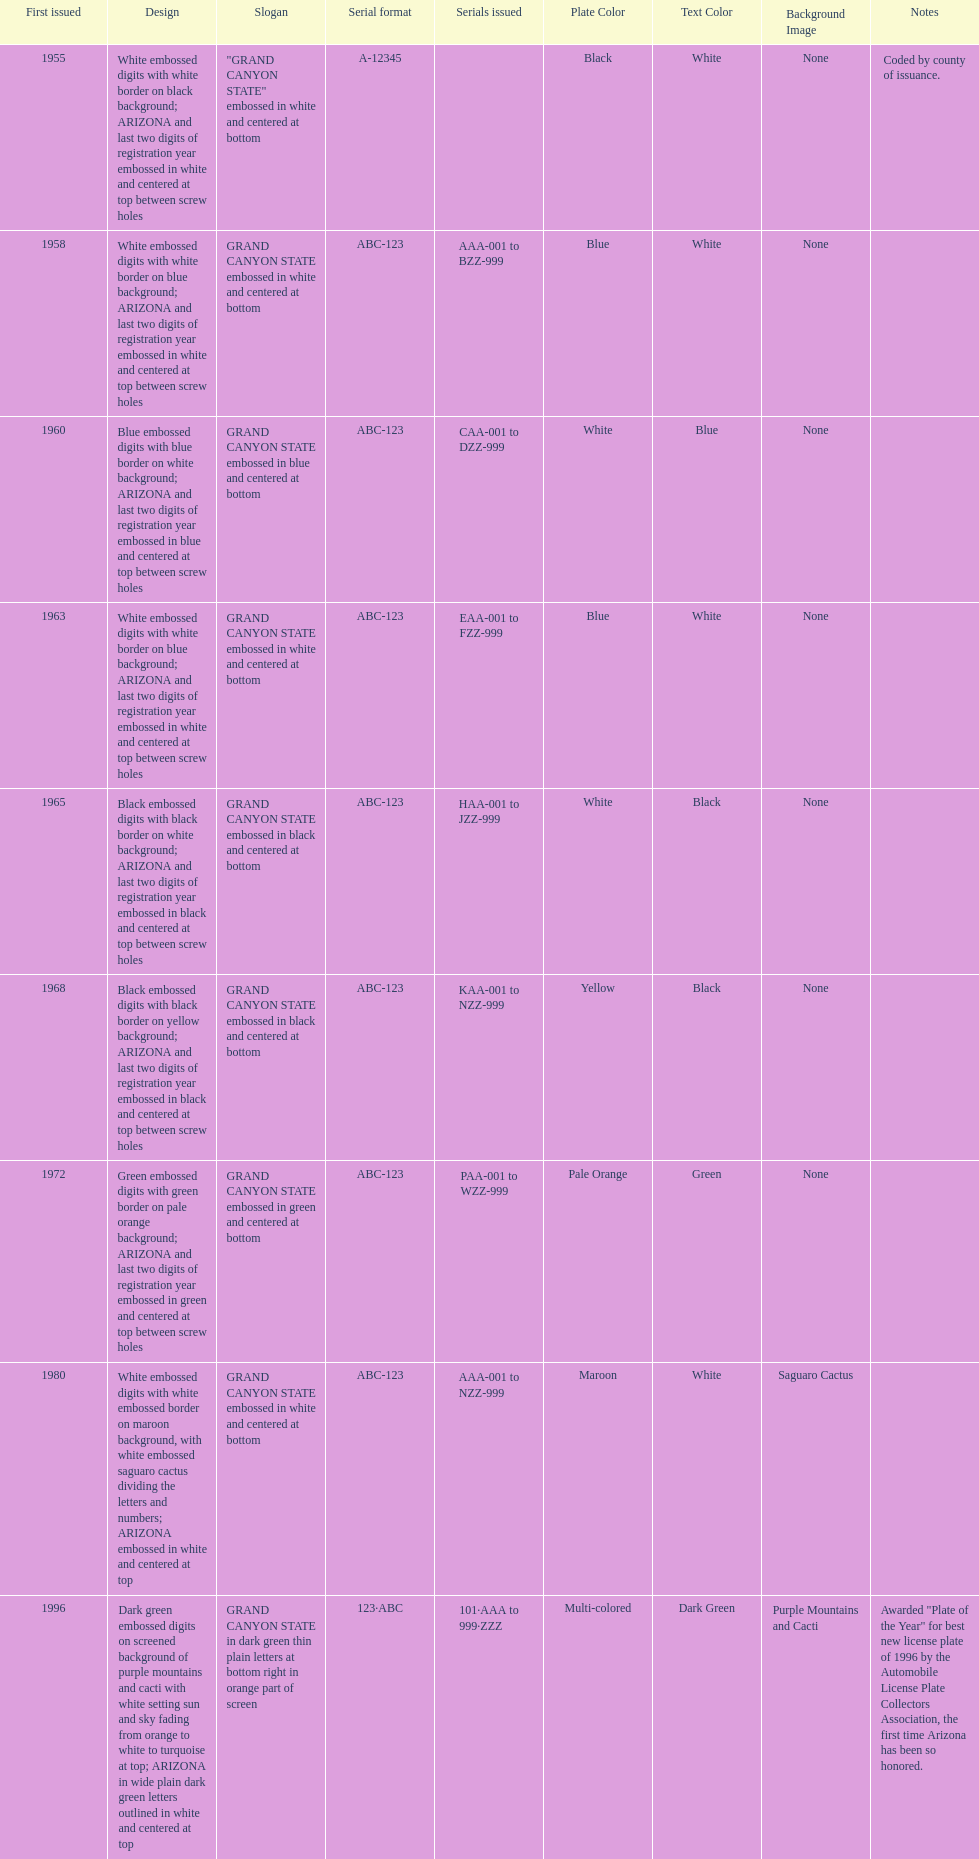What is the average serial format of the arizona license plates? ABC-123. 